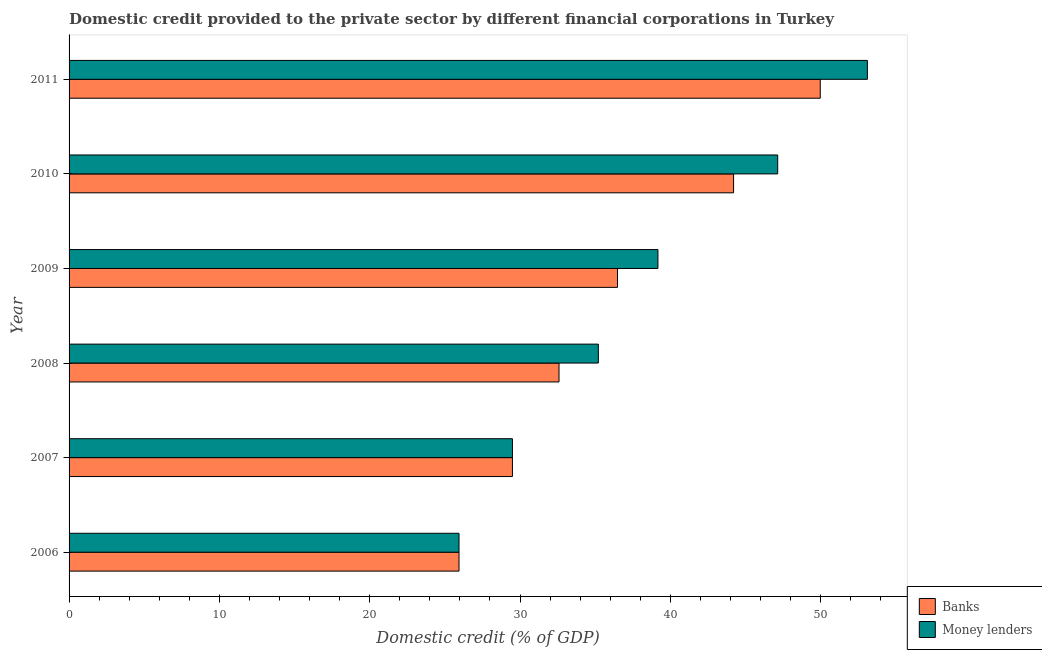How many different coloured bars are there?
Make the answer very short. 2. Are the number of bars on each tick of the Y-axis equal?
Your answer should be very brief. Yes. How many bars are there on the 3rd tick from the top?
Offer a very short reply. 2. What is the domestic credit provided by money lenders in 2008?
Offer a terse response. 35.21. Across all years, what is the maximum domestic credit provided by banks?
Your response must be concise. 49.97. Across all years, what is the minimum domestic credit provided by banks?
Offer a very short reply. 25.94. What is the total domestic credit provided by money lenders in the graph?
Ensure brevity in your answer.  230.07. What is the difference between the domestic credit provided by banks in 2007 and that in 2008?
Give a very brief answer. -3.1. What is the difference between the domestic credit provided by banks in 2008 and the domestic credit provided by money lenders in 2006?
Ensure brevity in your answer.  6.65. What is the average domestic credit provided by banks per year?
Offer a terse response. 36.45. In the year 2010, what is the difference between the domestic credit provided by banks and domestic credit provided by money lenders?
Provide a succinct answer. -2.94. In how many years, is the domestic credit provided by banks greater than 6 %?
Your response must be concise. 6. What is the ratio of the domestic credit provided by money lenders in 2006 to that in 2009?
Make the answer very short. 0.66. Is the domestic credit provided by banks in 2007 less than that in 2008?
Your response must be concise. Yes. Is the difference between the domestic credit provided by banks in 2008 and 2009 greater than the difference between the domestic credit provided by money lenders in 2008 and 2009?
Offer a terse response. Yes. What is the difference between the highest and the second highest domestic credit provided by money lenders?
Your answer should be very brief. 5.97. What is the difference between the highest and the lowest domestic credit provided by money lenders?
Give a very brief answer. 27.17. In how many years, is the domestic credit provided by banks greater than the average domestic credit provided by banks taken over all years?
Provide a succinct answer. 3. What does the 1st bar from the top in 2010 represents?
Provide a succinct answer. Money lenders. What does the 2nd bar from the bottom in 2011 represents?
Make the answer very short. Money lenders. Are the values on the major ticks of X-axis written in scientific E-notation?
Your response must be concise. No. Does the graph contain any zero values?
Offer a very short reply. No. Does the graph contain grids?
Give a very brief answer. No. Where does the legend appear in the graph?
Keep it short and to the point. Bottom right. How many legend labels are there?
Your answer should be very brief. 2. How are the legend labels stacked?
Keep it short and to the point. Vertical. What is the title of the graph?
Your answer should be very brief. Domestic credit provided to the private sector by different financial corporations in Turkey. What is the label or title of the X-axis?
Your response must be concise. Domestic credit (% of GDP). What is the Domestic credit (% of GDP) of Banks in 2006?
Your answer should be very brief. 25.94. What is the Domestic credit (% of GDP) of Money lenders in 2006?
Your response must be concise. 25.94. What is the Domestic credit (% of GDP) of Banks in 2007?
Provide a succinct answer. 29.5. What is the Domestic credit (% of GDP) in Money lenders in 2007?
Give a very brief answer. 29.5. What is the Domestic credit (% of GDP) of Banks in 2008?
Keep it short and to the point. 32.59. What is the Domestic credit (% of GDP) in Money lenders in 2008?
Give a very brief answer. 35.21. What is the Domestic credit (% of GDP) of Banks in 2009?
Offer a very short reply. 36.48. What is the Domestic credit (% of GDP) of Money lenders in 2009?
Provide a short and direct response. 39.18. What is the Domestic credit (% of GDP) in Banks in 2010?
Give a very brief answer. 44.21. What is the Domestic credit (% of GDP) in Money lenders in 2010?
Your answer should be compact. 47.14. What is the Domestic credit (% of GDP) in Banks in 2011?
Ensure brevity in your answer.  49.97. What is the Domestic credit (% of GDP) of Money lenders in 2011?
Give a very brief answer. 53.11. Across all years, what is the maximum Domestic credit (% of GDP) of Banks?
Ensure brevity in your answer.  49.97. Across all years, what is the maximum Domestic credit (% of GDP) in Money lenders?
Make the answer very short. 53.11. Across all years, what is the minimum Domestic credit (% of GDP) of Banks?
Offer a terse response. 25.94. Across all years, what is the minimum Domestic credit (% of GDP) of Money lenders?
Ensure brevity in your answer.  25.94. What is the total Domestic credit (% of GDP) of Banks in the graph?
Your answer should be compact. 218.7. What is the total Domestic credit (% of GDP) of Money lenders in the graph?
Your response must be concise. 230.07. What is the difference between the Domestic credit (% of GDP) in Banks in 2006 and that in 2007?
Provide a succinct answer. -3.55. What is the difference between the Domestic credit (% of GDP) of Money lenders in 2006 and that in 2007?
Your answer should be very brief. -3.55. What is the difference between the Domestic credit (% of GDP) of Banks in 2006 and that in 2008?
Offer a very short reply. -6.65. What is the difference between the Domestic credit (% of GDP) of Money lenders in 2006 and that in 2008?
Ensure brevity in your answer.  -9.27. What is the difference between the Domestic credit (% of GDP) in Banks in 2006 and that in 2009?
Your answer should be compact. -10.54. What is the difference between the Domestic credit (% of GDP) in Money lenders in 2006 and that in 2009?
Ensure brevity in your answer.  -13.23. What is the difference between the Domestic credit (% of GDP) of Banks in 2006 and that in 2010?
Make the answer very short. -18.27. What is the difference between the Domestic credit (% of GDP) of Money lenders in 2006 and that in 2010?
Give a very brief answer. -21.2. What is the difference between the Domestic credit (% of GDP) of Banks in 2006 and that in 2011?
Keep it short and to the point. -24.03. What is the difference between the Domestic credit (% of GDP) in Money lenders in 2006 and that in 2011?
Give a very brief answer. -27.17. What is the difference between the Domestic credit (% of GDP) in Banks in 2007 and that in 2008?
Offer a very short reply. -3.1. What is the difference between the Domestic credit (% of GDP) in Money lenders in 2007 and that in 2008?
Provide a short and direct response. -5.71. What is the difference between the Domestic credit (% of GDP) in Banks in 2007 and that in 2009?
Keep it short and to the point. -6.99. What is the difference between the Domestic credit (% of GDP) of Money lenders in 2007 and that in 2009?
Offer a terse response. -9.68. What is the difference between the Domestic credit (% of GDP) of Banks in 2007 and that in 2010?
Offer a very short reply. -14.71. What is the difference between the Domestic credit (% of GDP) of Money lenders in 2007 and that in 2010?
Your response must be concise. -17.65. What is the difference between the Domestic credit (% of GDP) of Banks in 2007 and that in 2011?
Your answer should be compact. -20.48. What is the difference between the Domestic credit (% of GDP) in Money lenders in 2007 and that in 2011?
Your answer should be compact. -23.61. What is the difference between the Domestic credit (% of GDP) in Banks in 2008 and that in 2009?
Make the answer very short. -3.89. What is the difference between the Domestic credit (% of GDP) in Money lenders in 2008 and that in 2009?
Provide a succinct answer. -3.96. What is the difference between the Domestic credit (% of GDP) in Banks in 2008 and that in 2010?
Your answer should be very brief. -11.61. What is the difference between the Domestic credit (% of GDP) of Money lenders in 2008 and that in 2010?
Keep it short and to the point. -11.93. What is the difference between the Domestic credit (% of GDP) of Banks in 2008 and that in 2011?
Offer a very short reply. -17.38. What is the difference between the Domestic credit (% of GDP) of Money lenders in 2008 and that in 2011?
Your answer should be compact. -17.9. What is the difference between the Domestic credit (% of GDP) in Banks in 2009 and that in 2010?
Provide a succinct answer. -7.72. What is the difference between the Domestic credit (% of GDP) of Money lenders in 2009 and that in 2010?
Ensure brevity in your answer.  -7.97. What is the difference between the Domestic credit (% of GDP) in Banks in 2009 and that in 2011?
Give a very brief answer. -13.49. What is the difference between the Domestic credit (% of GDP) in Money lenders in 2009 and that in 2011?
Make the answer very short. -13.93. What is the difference between the Domestic credit (% of GDP) of Banks in 2010 and that in 2011?
Your response must be concise. -5.77. What is the difference between the Domestic credit (% of GDP) in Money lenders in 2010 and that in 2011?
Your response must be concise. -5.97. What is the difference between the Domestic credit (% of GDP) of Banks in 2006 and the Domestic credit (% of GDP) of Money lenders in 2007?
Your answer should be compact. -3.55. What is the difference between the Domestic credit (% of GDP) in Banks in 2006 and the Domestic credit (% of GDP) in Money lenders in 2008?
Provide a succinct answer. -9.27. What is the difference between the Domestic credit (% of GDP) of Banks in 2006 and the Domestic credit (% of GDP) of Money lenders in 2009?
Give a very brief answer. -13.23. What is the difference between the Domestic credit (% of GDP) in Banks in 2006 and the Domestic credit (% of GDP) in Money lenders in 2010?
Your answer should be very brief. -21.2. What is the difference between the Domestic credit (% of GDP) in Banks in 2006 and the Domestic credit (% of GDP) in Money lenders in 2011?
Offer a terse response. -27.17. What is the difference between the Domestic credit (% of GDP) in Banks in 2007 and the Domestic credit (% of GDP) in Money lenders in 2008?
Offer a very short reply. -5.71. What is the difference between the Domestic credit (% of GDP) in Banks in 2007 and the Domestic credit (% of GDP) in Money lenders in 2009?
Offer a terse response. -9.68. What is the difference between the Domestic credit (% of GDP) of Banks in 2007 and the Domestic credit (% of GDP) of Money lenders in 2010?
Make the answer very short. -17.65. What is the difference between the Domestic credit (% of GDP) in Banks in 2007 and the Domestic credit (% of GDP) in Money lenders in 2011?
Provide a succinct answer. -23.61. What is the difference between the Domestic credit (% of GDP) in Banks in 2008 and the Domestic credit (% of GDP) in Money lenders in 2009?
Your answer should be very brief. -6.58. What is the difference between the Domestic credit (% of GDP) in Banks in 2008 and the Domestic credit (% of GDP) in Money lenders in 2010?
Ensure brevity in your answer.  -14.55. What is the difference between the Domestic credit (% of GDP) in Banks in 2008 and the Domestic credit (% of GDP) in Money lenders in 2011?
Ensure brevity in your answer.  -20.52. What is the difference between the Domestic credit (% of GDP) in Banks in 2009 and the Domestic credit (% of GDP) in Money lenders in 2010?
Make the answer very short. -10.66. What is the difference between the Domestic credit (% of GDP) of Banks in 2009 and the Domestic credit (% of GDP) of Money lenders in 2011?
Offer a terse response. -16.62. What is the difference between the Domestic credit (% of GDP) of Banks in 2010 and the Domestic credit (% of GDP) of Money lenders in 2011?
Your response must be concise. -8.9. What is the average Domestic credit (% of GDP) of Banks per year?
Keep it short and to the point. 36.45. What is the average Domestic credit (% of GDP) in Money lenders per year?
Offer a very short reply. 38.35. In the year 2007, what is the difference between the Domestic credit (% of GDP) of Banks and Domestic credit (% of GDP) of Money lenders?
Give a very brief answer. 0. In the year 2008, what is the difference between the Domestic credit (% of GDP) in Banks and Domestic credit (% of GDP) in Money lenders?
Your answer should be very brief. -2.62. In the year 2009, what is the difference between the Domestic credit (% of GDP) in Banks and Domestic credit (% of GDP) in Money lenders?
Keep it short and to the point. -2.69. In the year 2010, what is the difference between the Domestic credit (% of GDP) of Banks and Domestic credit (% of GDP) of Money lenders?
Keep it short and to the point. -2.94. In the year 2011, what is the difference between the Domestic credit (% of GDP) of Banks and Domestic credit (% of GDP) of Money lenders?
Give a very brief answer. -3.14. What is the ratio of the Domestic credit (% of GDP) in Banks in 2006 to that in 2007?
Keep it short and to the point. 0.88. What is the ratio of the Domestic credit (% of GDP) of Money lenders in 2006 to that in 2007?
Your answer should be very brief. 0.88. What is the ratio of the Domestic credit (% of GDP) in Banks in 2006 to that in 2008?
Keep it short and to the point. 0.8. What is the ratio of the Domestic credit (% of GDP) in Money lenders in 2006 to that in 2008?
Offer a terse response. 0.74. What is the ratio of the Domestic credit (% of GDP) of Banks in 2006 to that in 2009?
Give a very brief answer. 0.71. What is the ratio of the Domestic credit (% of GDP) of Money lenders in 2006 to that in 2009?
Give a very brief answer. 0.66. What is the ratio of the Domestic credit (% of GDP) in Banks in 2006 to that in 2010?
Ensure brevity in your answer.  0.59. What is the ratio of the Domestic credit (% of GDP) of Money lenders in 2006 to that in 2010?
Offer a terse response. 0.55. What is the ratio of the Domestic credit (% of GDP) of Banks in 2006 to that in 2011?
Offer a terse response. 0.52. What is the ratio of the Domestic credit (% of GDP) in Money lenders in 2006 to that in 2011?
Offer a very short reply. 0.49. What is the ratio of the Domestic credit (% of GDP) in Banks in 2007 to that in 2008?
Provide a succinct answer. 0.91. What is the ratio of the Domestic credit (% of GDP) in Money lenders in 2007 to that in 2008?
Offer a terse response. 0.84. What is the ratio of the Domestic credit (% of GDP) in Banks in 2007 to that in 2009?
Your answer should be very brief. 0.81. What is the ratio of the Domestic credit (% of GDP) in Money lenders in 2007 to that in 2009?
Give a very brief answer. 0.75. What is the ratio of the Domestic credit (% of GDP) of Banks in 2007 to that in 2010?
Provide a succinct answer. 0.67. What is the ratio of the Domestic credit (% of GDP) in Money lenders in 2007 to that in 2010?
Make the answer very short. 0.63. What is the ratio of the Domestic credit (% of GDP) in Banks in 2007 to that in 2011?
Give a very brief answer. 0.59. What is the ratio of the Domestic credit (% of GDP) in Money lenders in 2007 to that in 2011?
Offer a very short reply. 0.56. What is the ratio of the Domestic credit (% of GDP) of Banks in 2008 to that in 2009?
Keep it short and to the point. 0.89. What is the ratio of the Domestic credit (% of GDP) of Money lenders in 2008 to that in 2009?
Make the answer very short. 0.9. What is the ratio of the Domestic credit (% of GDP) in Banks in 2008 to that in 2010?
Offer a very short reply. 0.74. What is the ratio of the Domestic credit (% of GDP) in Money lenders in 2008 to that in 2010?
Your answer should be very brief. 0.75. What is the ratio of the Domestic credit (% of GDP) in Banks in 2008 to that in 2011?
Provide a succinct answer. 0.65. What is the ratio of the Domestic credit (% of GDP) of Money lenders in 2008 to that in 2011?
Offer a very short reply. 0.66. What is the ratio of the Domestic credit (% of GDP) in Banks in 2009 to that in 2010?
Give a very brief answer. 0.83. What is the ratio of the Domestic credit (% of GDP) of Money lenders in 2009 to that in 2010?
Offer a very short reply. 0.83. What is the ratio of the Domestic credit (% of GDP) of Banks in 2009 to that in 2011?
Offer a terse response. 0.73. What is the ratio of the Domestic credit (% of GDP) of Money lenders in 2009 to that in 2011?
Keep it short and to the point. 0.74. What is the ratio of the Domestic credit (% of GDP) of Banks in 2010 to that in 2011?
Your response must be concise. 0.88. What is the ratio of the Domestic credit (% of GDP) in Money lenders in 2010 to that in 2011?
Your answer should be very brief. 0.89. What is the difference between the highest and the second highest Domestic credit (% of GDP) of Banks?
Give a very brief answer. 5.77. What is the difference between the highest and the second highest Domestic credit (% of GDP) in Money lenders?
Ensure brevity in your answer.  5.97. What is the difference between the highest and the lowest Domestic credit (% of GDP) of Banks?
Your answer should be compact. 24.03. What is the difference between the highest and the lowest Domestic credit (% of GDP) in Money lenders?
Your response must be concise. 27.17. 